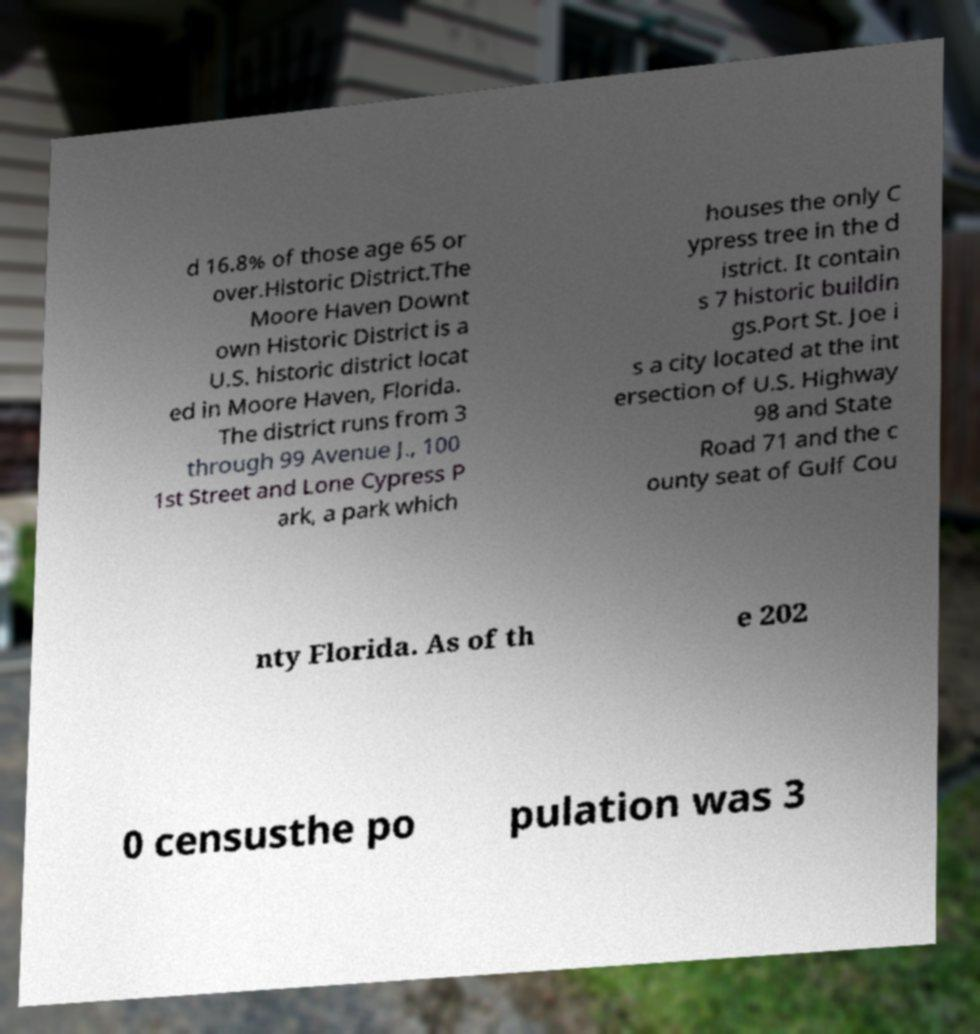For documentation purposes, I need the text within this image transcribed. Could you provide that? d 16.8% of those age 65 or over.Historic District.The Moore Haven Downt own Historic District is a U.S. historic district locat ed in Moore Haven, Florida. The district runs from 3 through 99 Avenue J., 100 1st Street and Lone Cypress P ark, a park which houses the only C ypress tree in the d istrict. It contain s 7 historic buildin gs.Port St. Joe i s a city located at the int ersection of U.S. Highway 98 and State Road 71 and the c ounty seat of Gulf Cou nty Florida. As of th e 202 0 censusthe po pulation was 3 